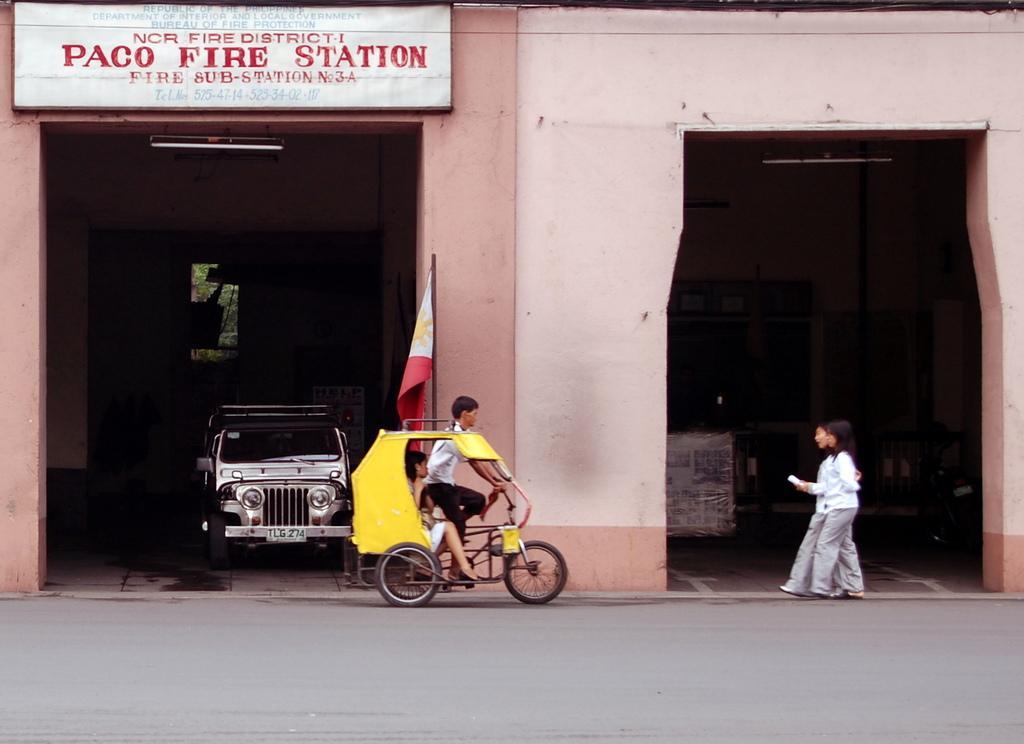Please provide a concise description of this image. In this image I can see two women walking and here is a small auto rickshaw where a man is riding. This is a flag with its pole. I can see a jeep which is kept inside the shed. This is the tube light attached to the wall. This place looks like a fire station as it is written on the name board which is attached to the building. I can see some other object inside the shed. 